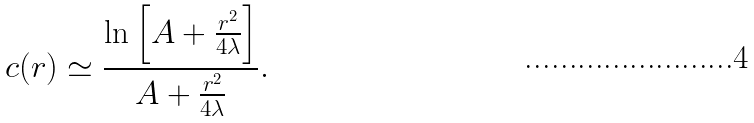Convert formula to latex. <formula><loc_0><loc_0><loc_500><loc_500>c ( r ) \simeq \frac { \ln \left [ A + \frac { r ^ { 2 } } { 4 \lambda } \right ] } { A + \frac { r ^ { 2 } } { 4 \lambda } } .</formula> 